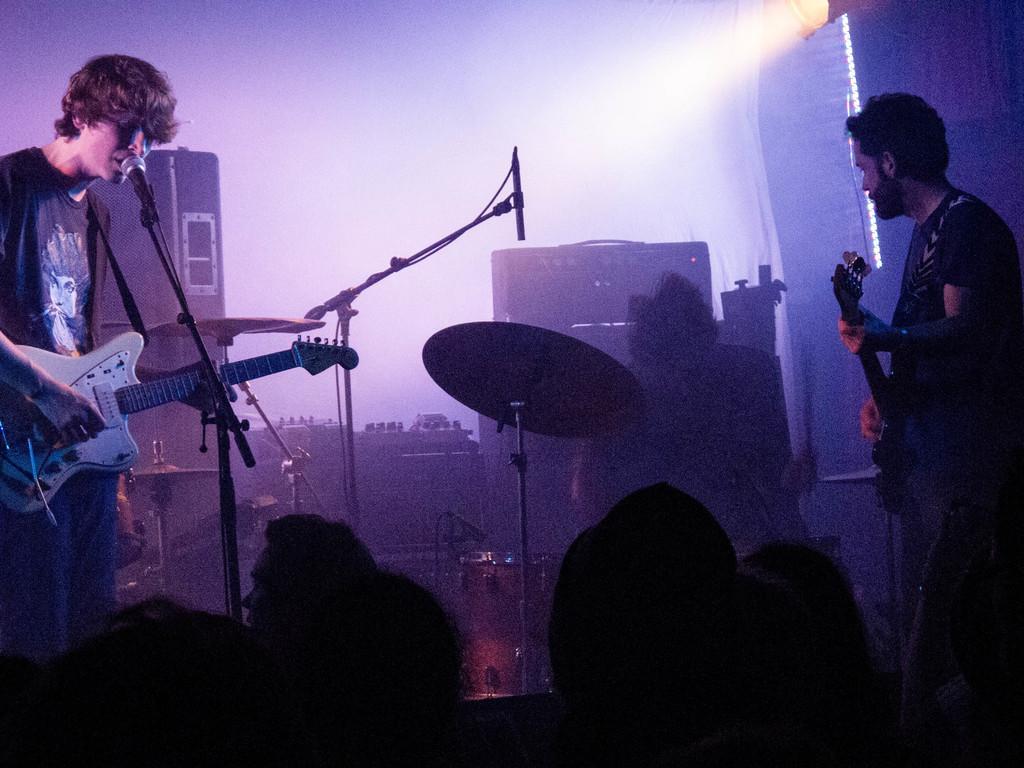Can you describe this image briefly? in the picture we can see a person standing near the micro phone holding a guitar and singing,the other person is standing and holding a guitar,we can persons standing in front of them and watching them ,we can see a scenery with a building. 